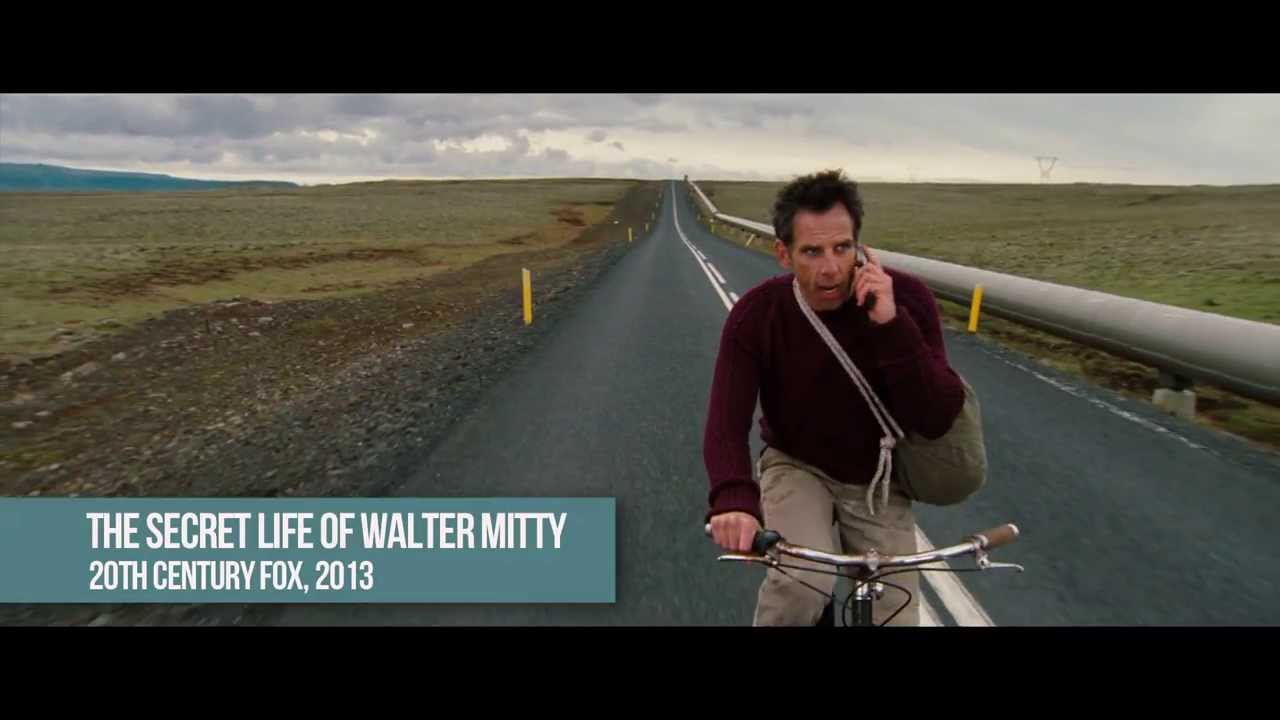What emotions does the image evoke upon first glance? The image evokes feelings of solitude and introspection. The barren landscape and the long, empty road create a sense of isolation, while the overcast sky contributes to a somber and reflective mood. The actor's worried expression and focused demeanor add a layer of tension and urgency, suggesting an underlying emotional complexity. 